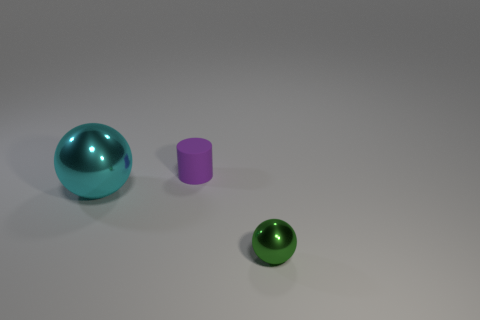Add 2 large cyan metallic objects. How many objects exist? 5 Subtract all cylinders. How many objects are left? 2 Subtract 0 red spheres. How many objects are left? 3 Subtract 1 spheres. How many spheres are left? 1 Subtract all green cylinders. Subtract all yellow spheres. How many cylinders are left? 1 Subtract all cyan cubes. How many green spheres are left? 1 Subtract all tiny red blocks. Subtract all big metal spheres. How many objects are left? 2 Add 3 cylinders. How many cylinders are left? 4 Add 1 gray shiny things. How many gray shiny things exist? 1 